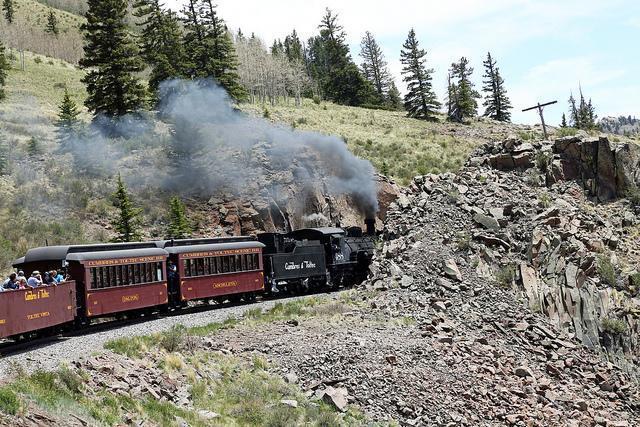How many green buses can you see?
Give a very brief answer. 0. 